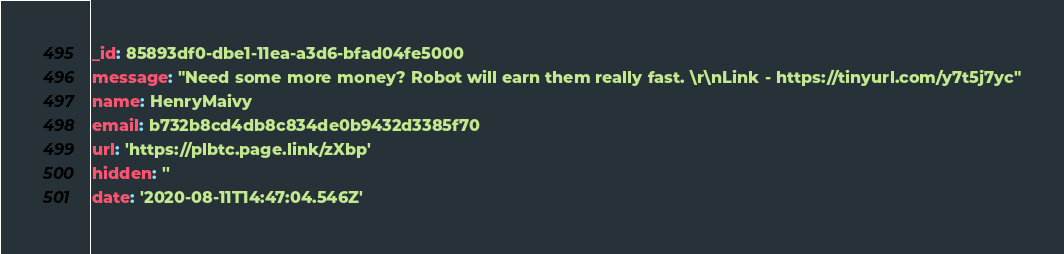<code> <loc_0><loc_0><loc_500><loc_500><_YAML_>_id: 85893df0-dbe1-11ea-a3d6-bfad04fe5000
message: "Need some more money? Robot will earn them really fast. \r\nLink - https://tinyurl.com/y7t5j7yc"
name: HenryMaivy
email: b732b8cd4db8c834de0b9432d3385f70
url: 'https://plbtc.page.link/zXbp'
hidden: ''
date: '2020-08-11T14:47:04.546Z'
</code> 